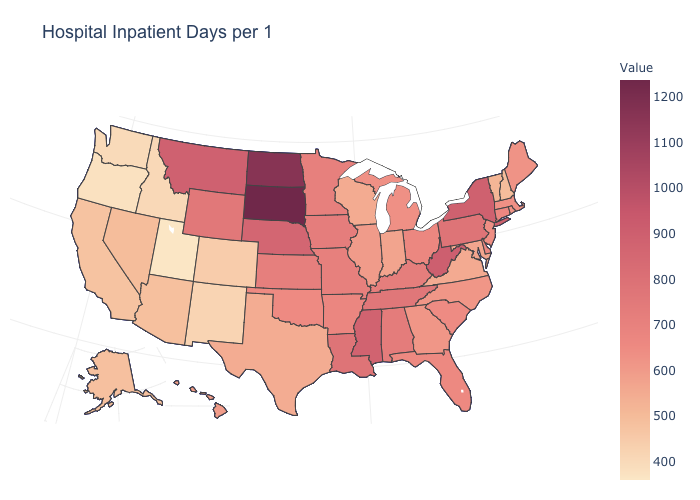Is the legend a continuous bar?
Concise answer only. Yes. Does Kansas have the highest value in the MidWest?
Write a very short answer. No. Among the states that border Pennsylvania , which have the lowest value?
Answer briefly. Maryland. Does New York have the highest value in the Northeast?
Be succinct. Yes. Does the map have missing data?
Short answer required. No. Which states have the lowest value in the USA?
Answer briefly. Utah. Does the map have missing data?
Write a very short answer. No. Which states have the highest value in the USA?
Answer briefly. South Dakota. 